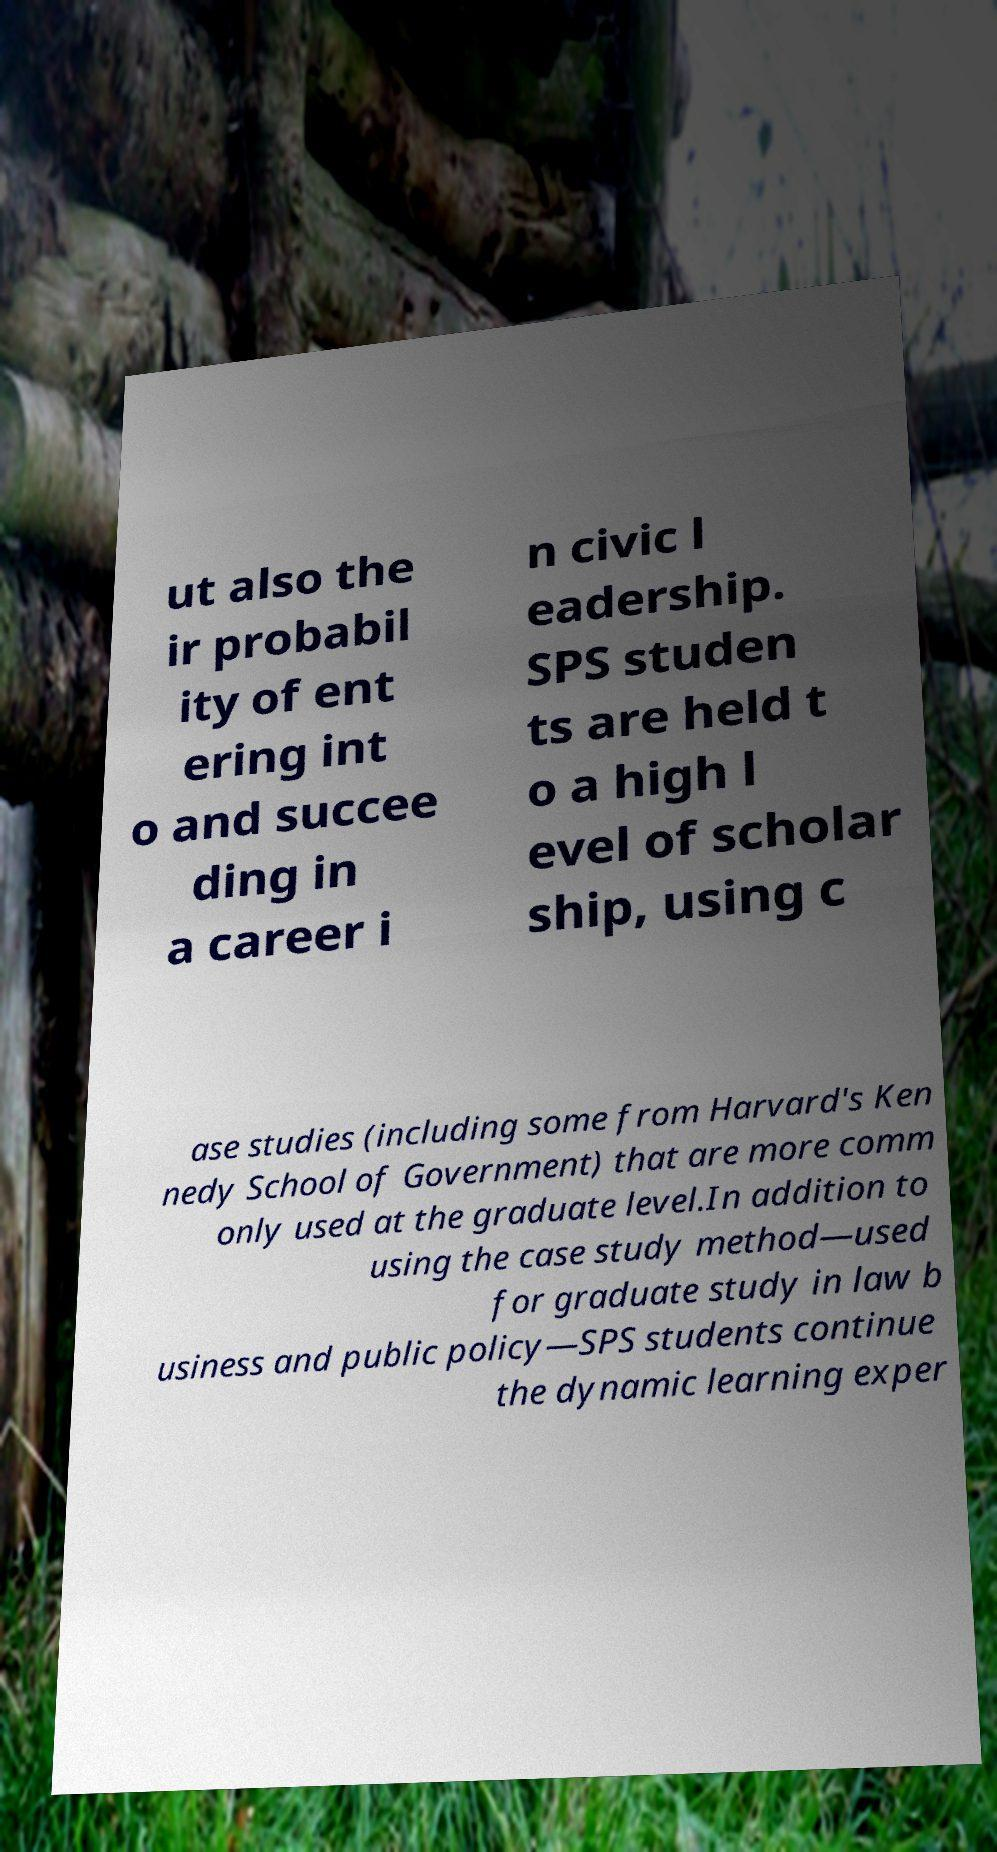What messages or text are displayed in this image? I need them in a readable, typed format. ut also the ir probabil ity of ent ering int o and succee ding in a career i n civic l eadership. SPS studen ts are held t o a high l evel of scholar ship, using c ase studies (including some from Harvard's Ken nedy School of Government) that are more comm only used at the graduate level.In addition to using the case study method—used for graduate study in law b usiness and public policy—SPS students continue the dynamic learning exper 